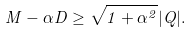Convert formula to latex. <formula><loc_0><loc_0><loc_500><loc_500>M - \alpha D \geq \sqrt { 1 + \alpha ^ { 2 } } | Q | .</formula> 